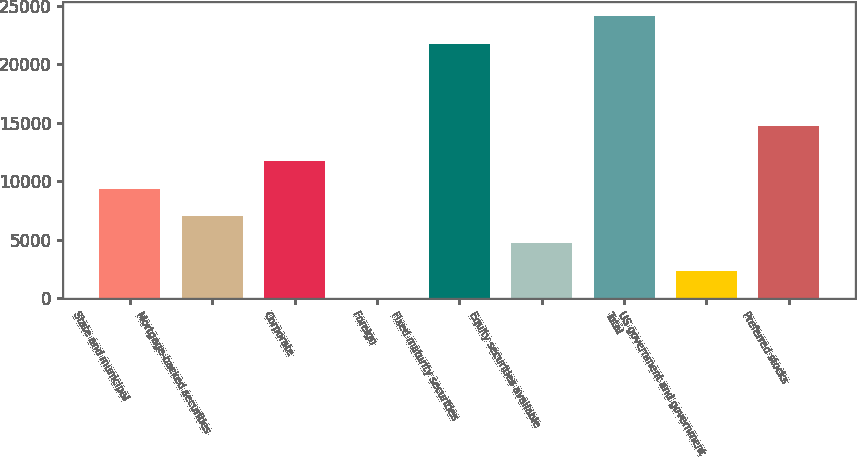Convert chart. <chart><loc_0><loc_0><loc_500><loc_500><bar_chart><fcel>State and municipal<fcel>Mortgage-backed securities<fcel>Corporate<fcel>Foreign<fcel>Fixed maturity securities<fcel>Equity securities available<fcel>Total<fcel>US government and government<fcel>Preferred stocks<nl><fcel>9386<fcel>7046.5<fcel>11725.5<fcel>28<fcel>21772<fcel>4707<fcel>24111.5<fcel>2367.5<fcel>14740<nl></chart> 